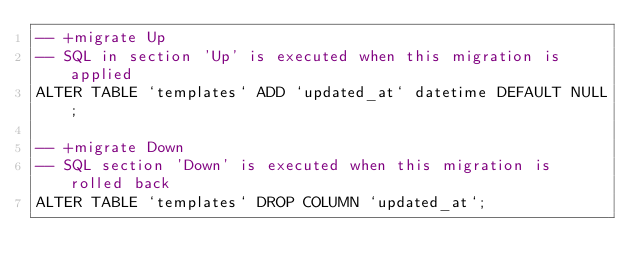Convert code to text. <code><loc_0><loc_0><loc_500><loc_500><_SQL_>-- +migrate Up
-- SQL in section 'Up' is executed when this migration is applied
ALTER TABLE `templates` ADD `updated_at` datetime DEFAULT NULL;

-- +migrate Down
-- SQL section 'Down' is executed when this migration is rolled back
ALTER TABLE `templates` DROP COLUMN `updated_at`;
</code> 